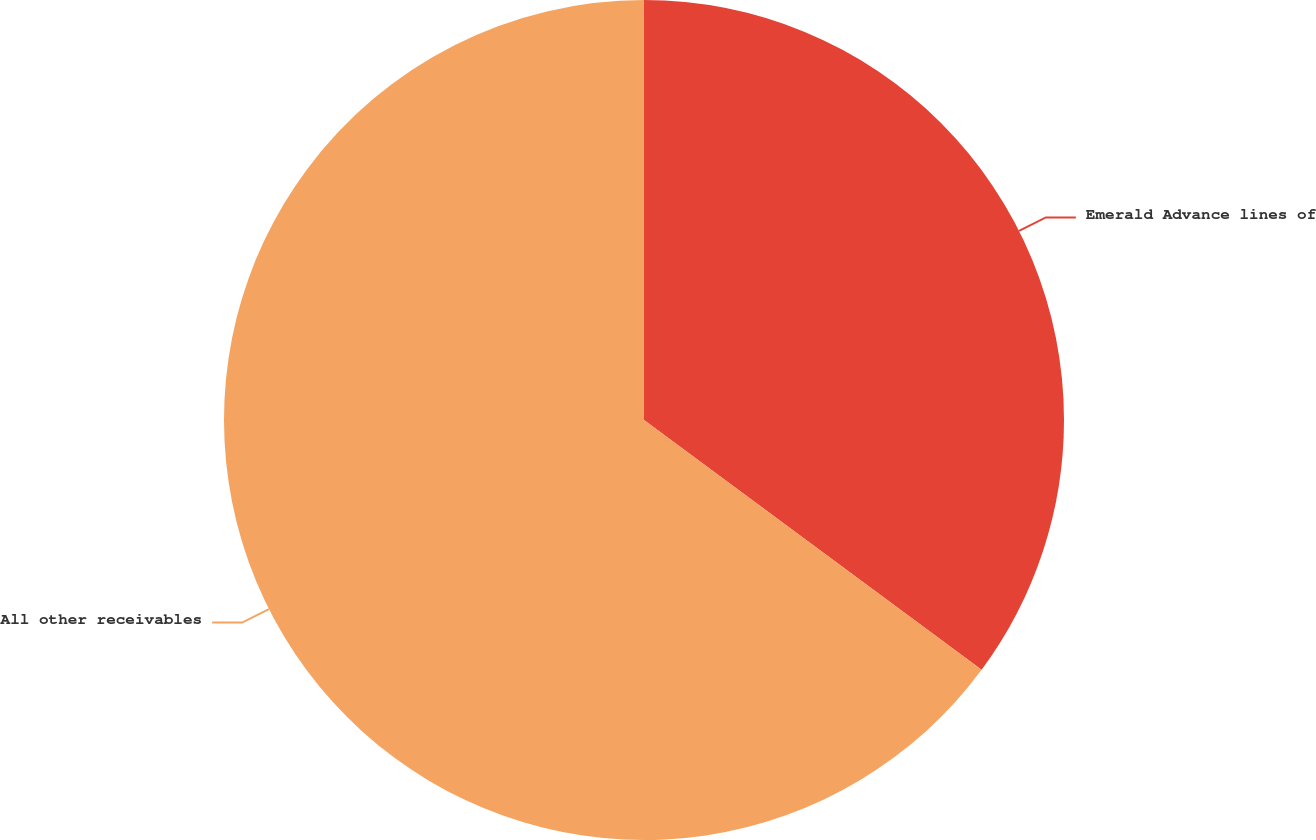Convert chart to OTSL. <chart><loc_0><loc_0><loc_500><loc_500><pie_chart><fcel>Emerald Advance lines of<fcel>All other receivables<nl><fcel>35.14%<fcel>64.86%<nl></chart> 